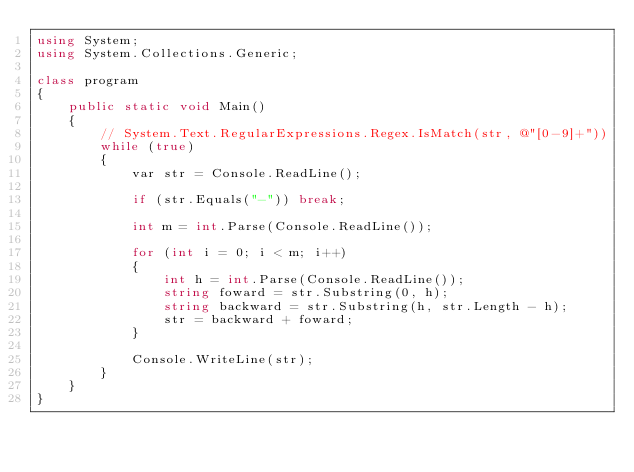<code> <loc_0><loc_0><loc_500><loc_500><_C#_>using System;
using System.Collections.Generic;

class program
{
    public static void Main()
    {
        // System.Text.RegularExpressions.Regex.IsMatch(str, @"[0-9]+"))
        while (true)
        {
            var str = Console.ReadLine();

            if (str.Equals("-")) break;

            int m = int.Parse(Console.ReadLine());

            for (int i = 0; i < m; i++)
            {
                int h = int.Parse(Console.ReadLine());
                string foward = str.Substring(0, h);
                string backward = str.Substring(h, str.Length - h);
                str = backward + foward;
            }

            Console.WriteLine(str);
        }
    }
}</code> 